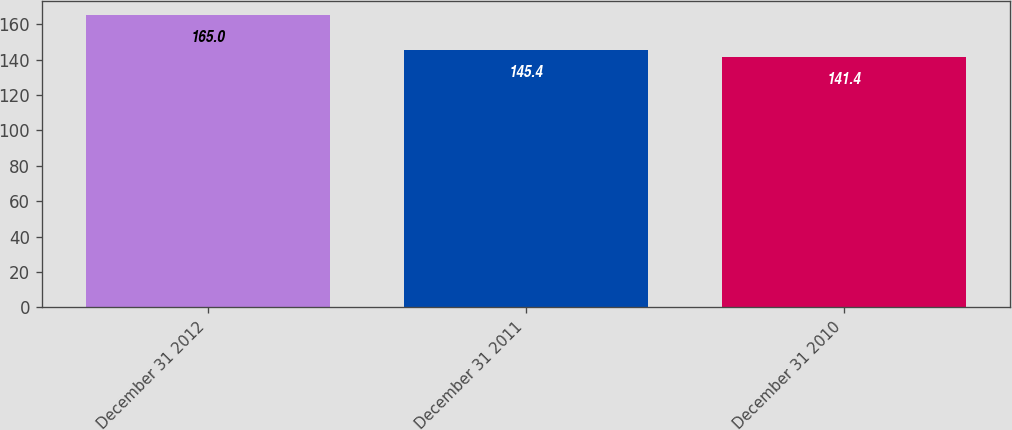Convert chart to OTSL. <chart><loc_0><loc_0><loc_500><loc_500><bar_chart><fcel>December 31 2012<fcel>December 31 2011<fcel>December 31 2010<nl><fcel>165<fcel>145.4<fcel>141.4<nl></chart> 